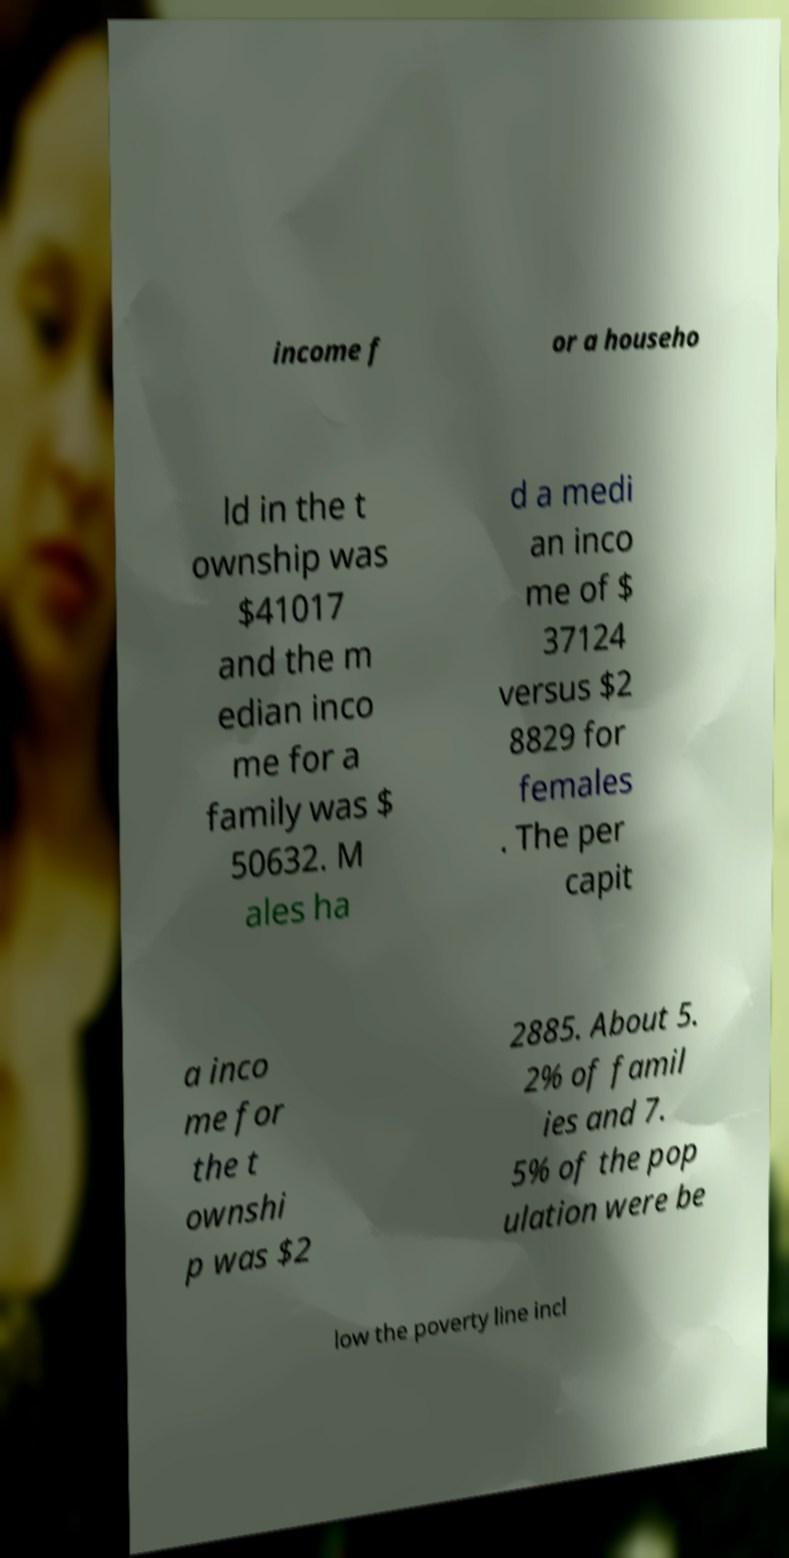Could you assist in decoding the text presented in this image and type it out clearly? income f or a househo ld in the t ownship was $41017 and the m edian inco me for a family was $ 50632. M ales ha d a medi an inco me of $ 37124 versus $2 8829 for females . The per capit a inco me for the t ownshi p was $2 2885. About 5. 2% of famil ies and 7. 5% of the pop ulation were be low the poverty line incl 